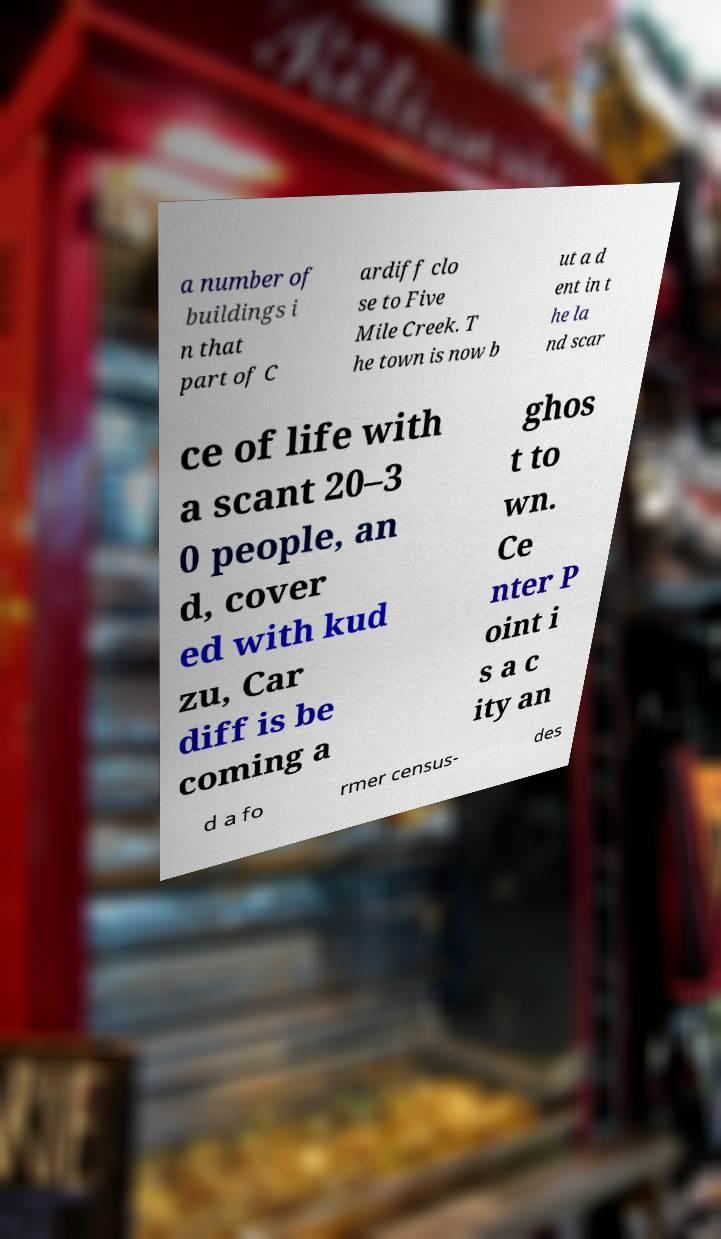Please identify and transcribe the text found in this image. a number of buildings i n that part of C ardiff clo se to Five Mile Creek. T he town is now b ut a d ent in t he la nd scar ce of life with a scant 20–3 0 people, an d, cover ed with kud zu, Car diff is be coming a ghos t to wn. Ce nter P oint i s a c ity an d a fo rmer census- des 